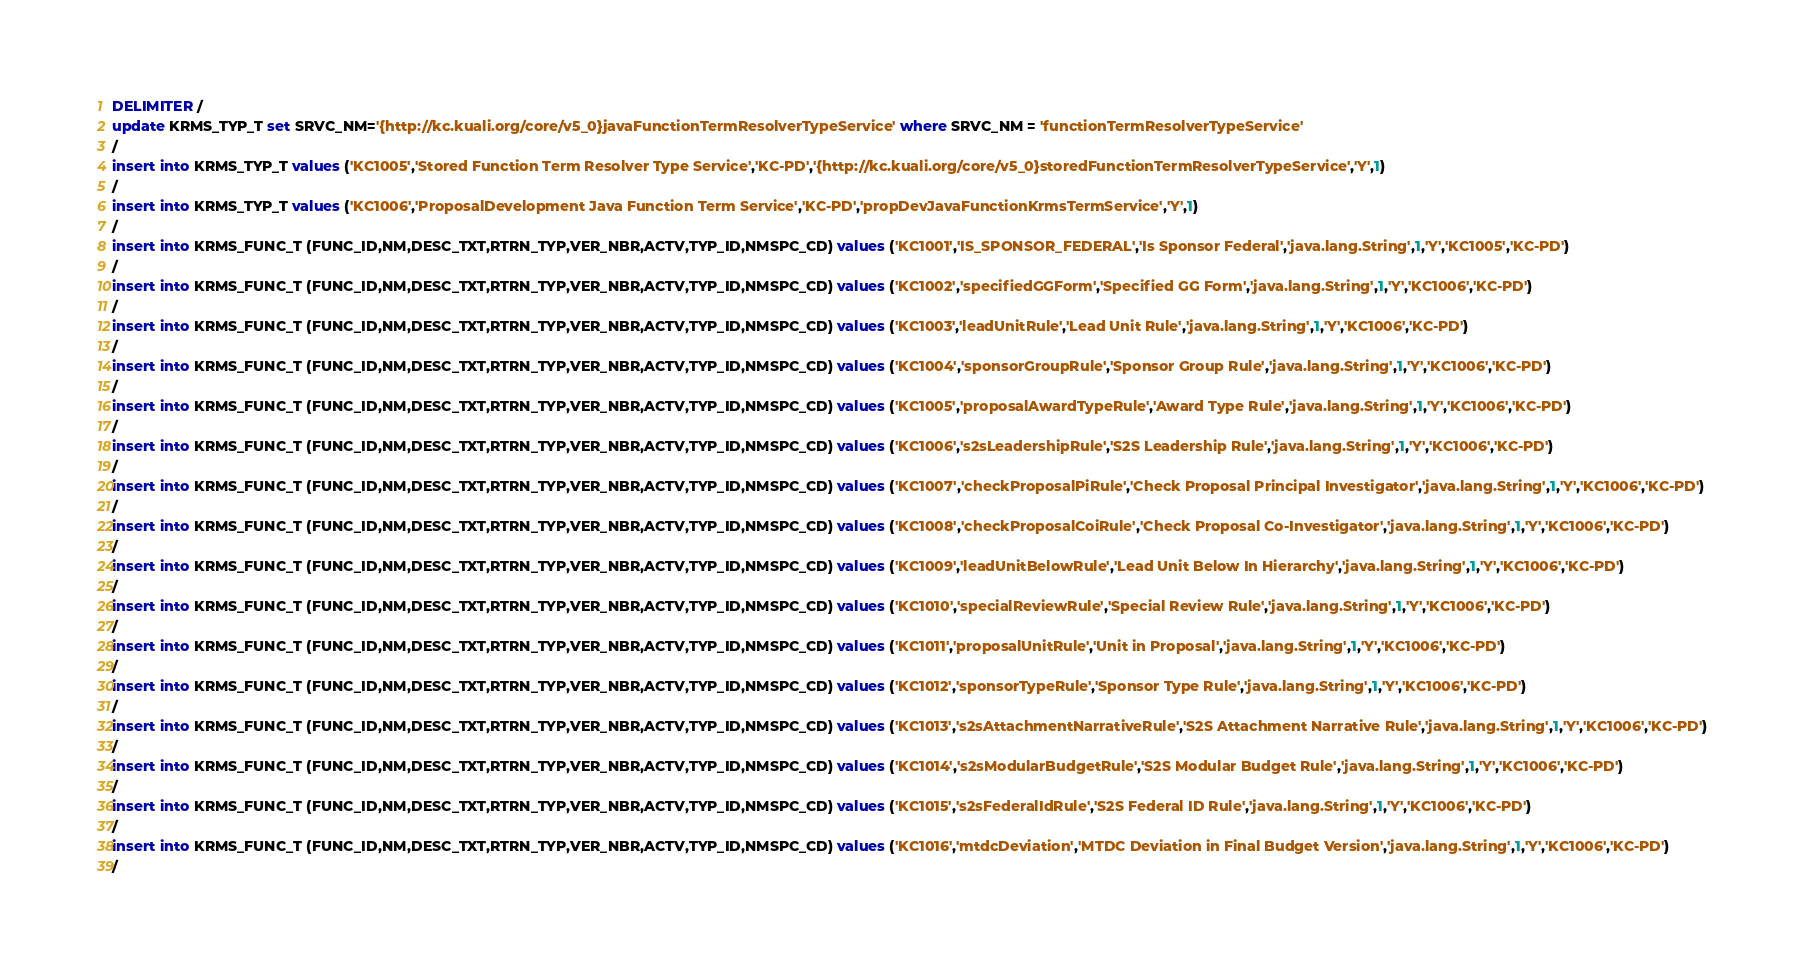<code> <loc_0><loc_0><loc_500><loc_500><_SQL_>DELIMITER /
update KRMS_TYP_T set SRVC_NM='{http://kc.kuali.org/core/v5_0}javaFunctionTermResolverTypeService' where SRVC_NM = 'functionTermResolverTypeService'
/
insert into KRMS_TYP_T values ('KC1005','Stored Function Term Resolver Type Service','KC-PD','{http://kc.kuali.org/core/v5_0}storedFunctionTermResolverTypeService','Y',1)
/
insert into KRMS_TYP_T values ('KC1006','ProposalDevelopment Java Function Term Service','KC-PD','propDevJavaFunctionKrmsTermService','Y',1)
/
insert into KRMS_FUNC_T (FUNC_ID,NM,DESC_TXT,RTRN_TYP,VER_NBR,ACTV,TYP_ID,NMSPC_CD) values ('KC1001','IS_SPONSOR_FEDERAL','Is Sponsor Federal','java.lang.String',1,'Y','KC1005','KC-PD')
/
insert into KRMS_FUNC_T (FUNC_ID,NM,DESC_TXT,RTRN_TYP,VER_NBR,ACTV,TYP_ID,NMSPC_CD) values ('KC1002','specifiedGGForm','Specified GG Form','java.lang.String',1,'Y','KC1006','KC-PD')
/
insert into KRMS_FUNC_T (FUNC_ID,NM,DESC_TXT,RTRN_TYP,VER_NBR,ACTV,TYP_ID,NMSPC_CD) values ('KC1003','leadUnitRule','Lead Unit Rule','java.lang.String',1,'Y','KC1006','KC-PD')
/
insert into KRMS_FUNC_T (FUNC_ID,NM,DESC_TXT,RTRN_TYP,VER_NBR,ACTV,TYP_ID,NMSPC_CD) values ('KC1004','sponsorGroupRule','Sponsor Group Rule','java.lang.String',1,'Y','KC1006','KC-PD')
/
insert into KRMS_FUNC_T (FUNC_ID,NM,DESC_TXT,RTRN_TYP,VER_NBR,ACTV,TYP_ID,NMSPC_CD) values ('KC1005','proposalAwardTypeRule','Award Type Rule','java.lang.String',1,'Y','KC1006','KC-PD')
/
insert into KRMS_FUNC_T (FUNC_ID,NM,DESC_TXT,RTRN_TYP,VER_NBR,ACTV,TYP_ID,NMSPC_CD) values ('KC1006','s2sLeadershipRule','S2S Leadership Rule','java.lang.String',1,'Y','KC1006','KC-PD')
/
insert into KRMS_FUNC_T (FUNC_ID,NM,DESC_TXT,RTRN_TYP,VER_NBR,ACTV,TYP_ID,NMSPC_CD) values ('KC1007','checkProposalPiRule','Check Proposal Principal Investigator','java.lang.String',1,'Y','KC1006','KC-PD')
/
insert into KRMS_FUNC_T (FUNC_ID,NM,DESC_TXT,RTRN_TYP,VER_NBR,ACTV,TYP_ID,NMSPC_CD) values ('KC1008','checkProposalCoiRule','Check Proposal Co-Investigator','java.lang.String',1,'Y','KC1006','KC-PD')
/
insert into KRMS_FUNC_T (FUNC_ID,NM,DESC_TXT,RTRN_TYP,VER_NBR,ACTV,TYP_ID,NMSPC_CD) values ('KC1009','leadUnitBelowRule','Lead Unit Below In Hierarchy','java.lang.String',1,'Y','KC1006','KC-PD')
/
insert into KRMS_FUNC_T (FUNC_ID,NM,DESC_TXT,RTRN_TYP,VER_NBR,ACTV,TYP_ID,NMSPC_CD) values ('KC1010','specialReviewRule','Special Review Rule','java.lang.String',1,'Y','KC1006','KC-PD')
/
insert into KRMS_FUNC_T (FUNC_ID,NM,DESC_TXT,RTRN_TYP,VER_NBR,ACTV,TYP_ID,NMSPC_CD) values ('KC1011','proposalUnitRule','Unit in Proposal','java.lang.String',1,'Y','KC1006','KC-PD')
/
insert into KRMS_FUNC_T (FUNC_ID,NM,DESC_TXT,RTRN_TYP,VER_NBR,ACTV,TYP_ID,NMSPC_CD) values ('KC1012','sponsorTypeRule','Sponsor Type Rule','java.lang.String',1,'Y','KC1006','KC-PD')
/
insert into KRMS_FUNC_T (FUNC_ID,NM,DESC_TXT,RTRN_TYP,VER_NBR,ACTV,TYP_ID,NMSPC_CD) values ('KC1013','s2sAttachmentNarrativeRule','S2S Attachment Narrative Rule','java.lang.String',1,'Y','KC1006','KC-PD')
/
insert into KRMS_FUNC_T (FUNC_ID,NM,DESC_TXT,RTRN_TYP,VER_NBR,ACTV,TYP_ID,NMSPC_CD) values ('KC1014','s2sModularBudgetRule','S2S Modular Budget Rule','java.lang.String',1,'Y','KC1006','KC-PD')
/
insert into KRMS_FUNC_T (FUNC_ID,NM,DESC_TXT,RTRN_TYP,VER_NBR,ACTV,TYP_ID,NMSPC_CD) values ('KC1015','s2sFederalIdRule','S2S Federal ID Rule','java.lang.String',1,'Y','KC1006','KC-PD')
/
insert into KRMS_FUNC_T (FUNC_ID,NM,DESC_TXT,RTRN_TYP,VER_NBR,ACTV,TYP_ID,NMSPC_CD) values ('KC1016','mtdcDeviation','MTDC Deviation in Final Budget Version','java.lang.String',1,'Y','KC1006','KC-PD')
/</code> 